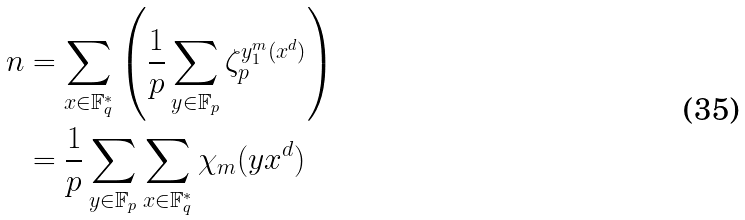<formula> <loc_0><loc_0><loc_500><loc_500>n & = \sum _ { x \in \mathbb { F } _ { q } ^ { * } } \left ( \frac { 1 } { p } \sum _ { y \in \mathbb { F } _ { p } } \zeta _ { p } ^ { y ^ { m } _ { 1 } ( x ^ { d } ) } \right ) \\ & = \frac { 1 } { p } \sum _ { y \in \mathbb { F } _ { p } } \sum _ { x \in \mathbb { F } _ { q } ^ { * } } \chi _ { m } ( y x ^ { d } )</formula> 